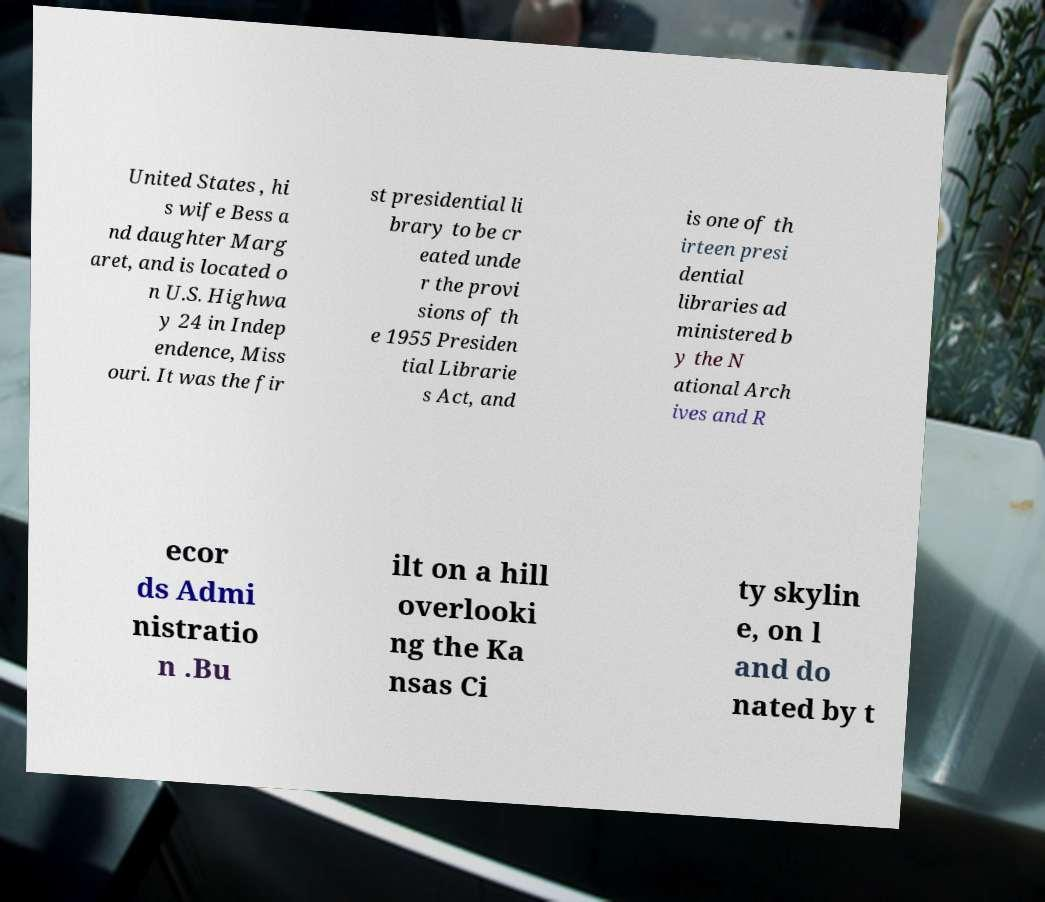Can you read and provide the text displayed in the image?This photo seems to have some interesting text. Can you extract and type it out for me? United States , hi s wife Bess a nd daughter Marg aret, and is located o n U.S. Highwa y 24 in Indep endence, Miss ouri. It was the fir st presidential li brary to be cr eated unde r the provi sions of th e 1955 Presiden tial Librarie s Act, and is one of th irteen presi dential libraries ad ministered b y the N ational Arch ives and R ecor ds Admi nistratio n .Bu ilt on a hill overlooki ng the Ka nsas Ci ty skylin e, on l and do nated by t 